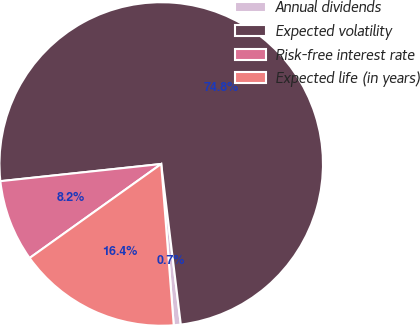Convert chart. <chart><loc_0><loc_0><loc_500><loc_500><pie_chart><fcel>Annual dividends<fcel>Expected volatility<fcel>Risk-free interest rate<fcel>Expected life (in years)<nl><fcel>0.7%<fcel>74.77%<fcel>8.18%<fcel>16.36%<nl></chart> 